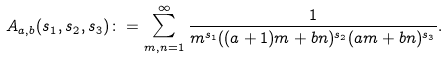<formula> <loc_0><loc_0><loc_500><loc_500>A _ { a , b } ( s _ { 1 } , s _ { 2 } , s _ { 3 } ) \colon = \sum _ { m , n = 1 } ^ { \infty } \frac { 1 } { m ^ { s _ { 1 } } ( ( a + 1 ) m + b n ) ^ { s _ { 2 } } ( a m + b n ) ^ { s _ { 3 } } } .</formula> 